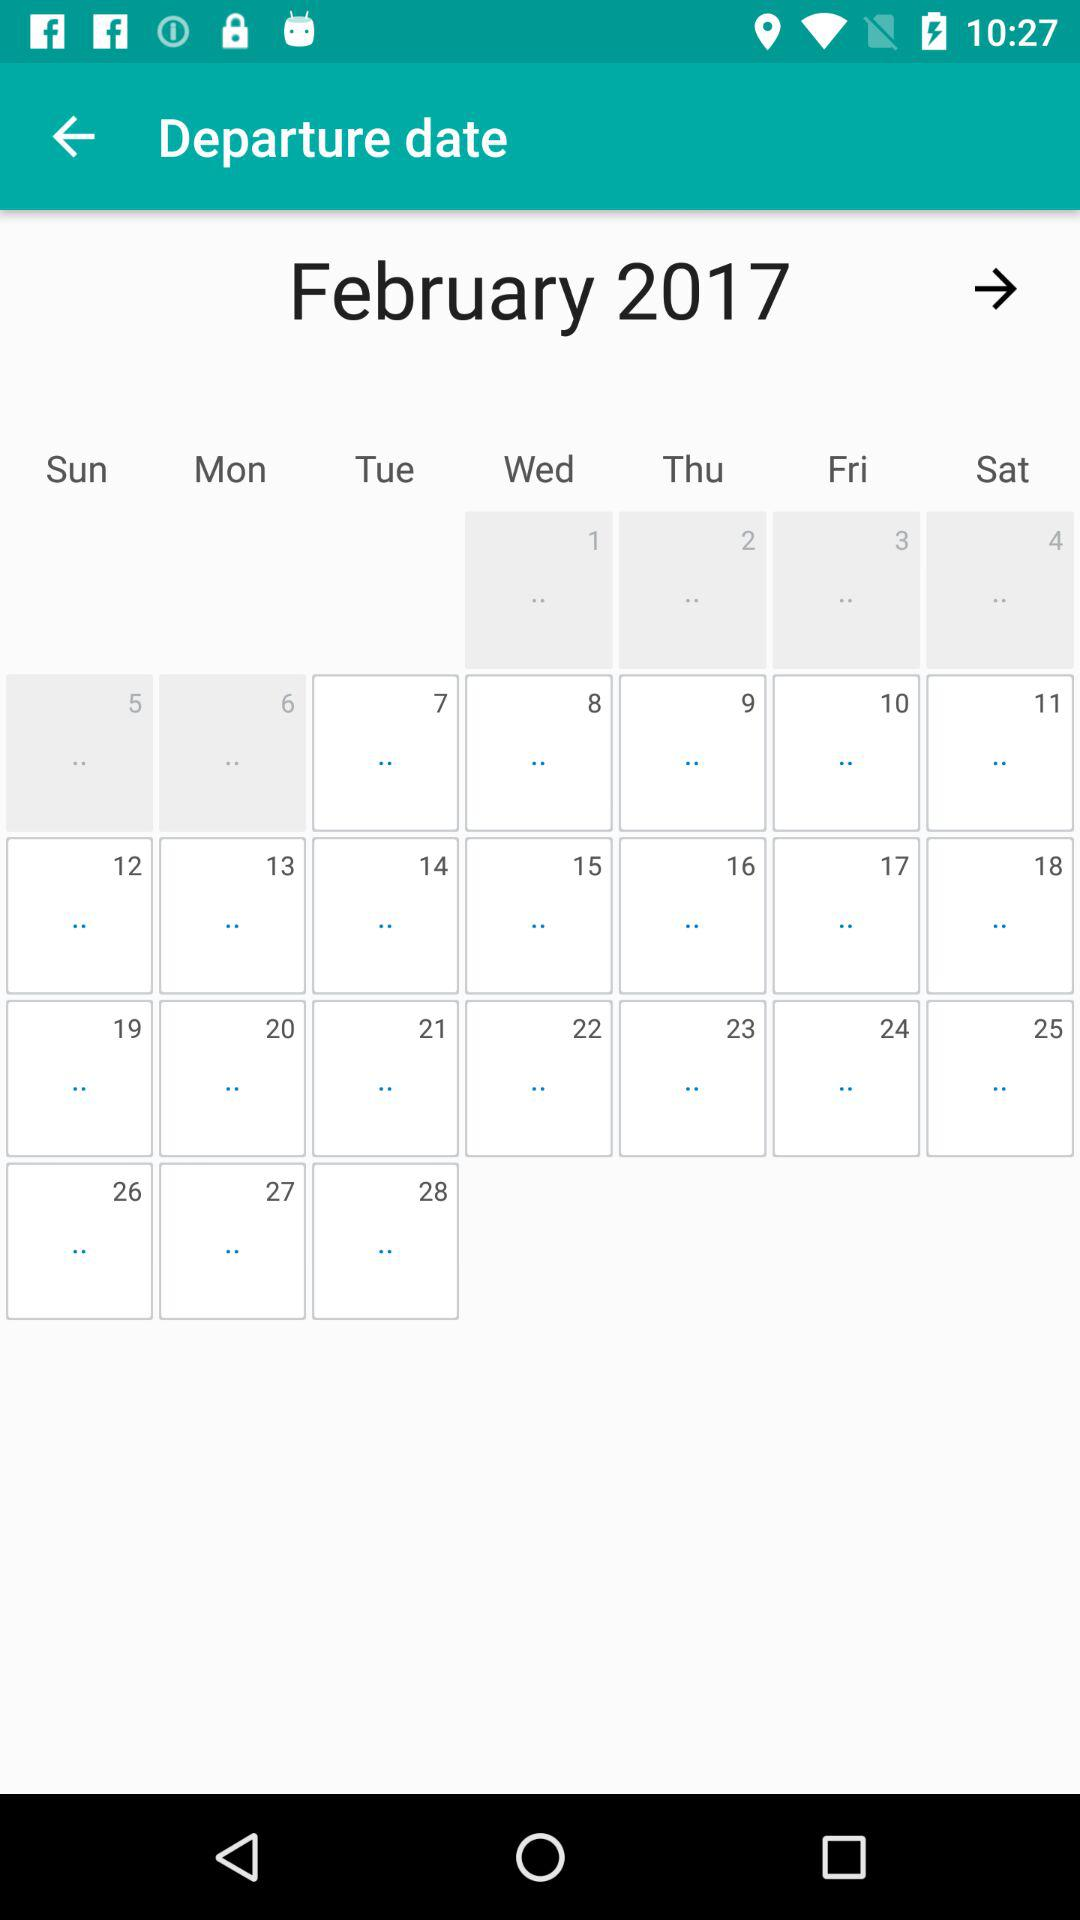What is the selected month? The selected month is February. 